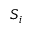Convert formula to latex. <formula><loc_0><loc_0><loc_500><loc_500>S _ { i }</formula> 